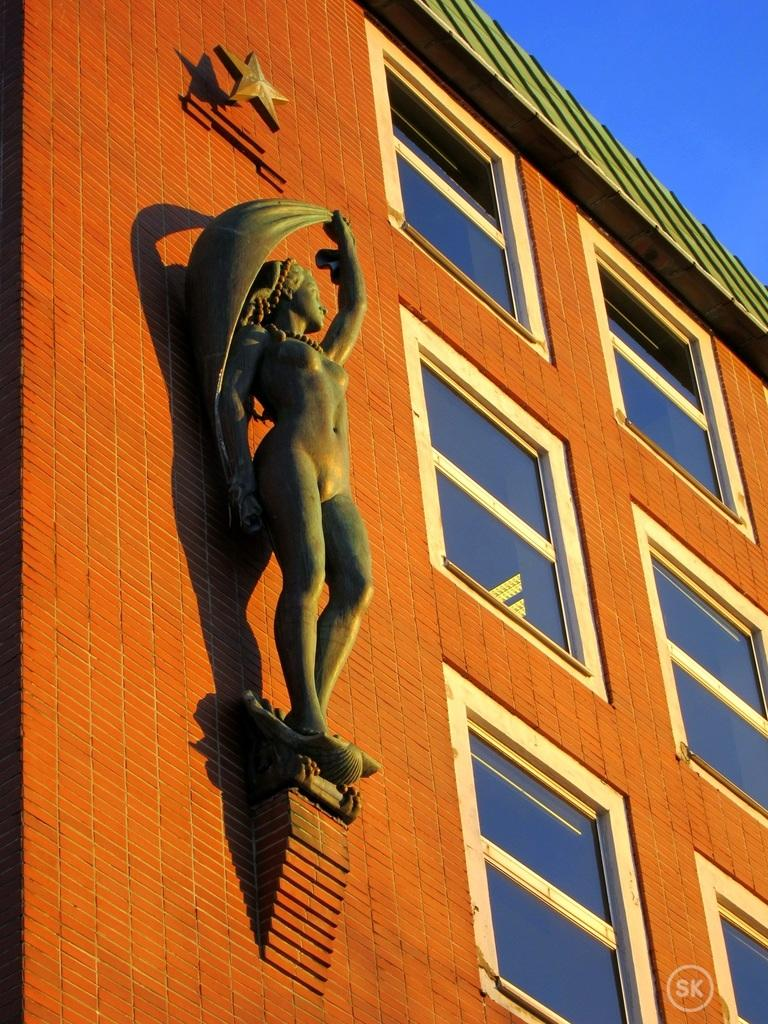What is located on the left side of the image? There is a star and a statue on the left side of the image. What is the color of the building's wall? The wall of the building is orange in color. What is the roof of the building like? The building has a roof. What type of windows does the building have? The building has glass windows. What can be seen in the background of the image? The background of the image includes a blue sky. What type of furniture is visible in the image? There is no furniture present in the image. Is the building in the image a coal mine? No, there is no indication that the building is a coal mine or related to coal in any way. 